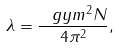<formula> <loc_0><loc_0><loc_500><loc_500>\lambda = \frac { \ g y m ^ { 2 } N } { 4 \pi ^ { 2 } } ,</formula> 